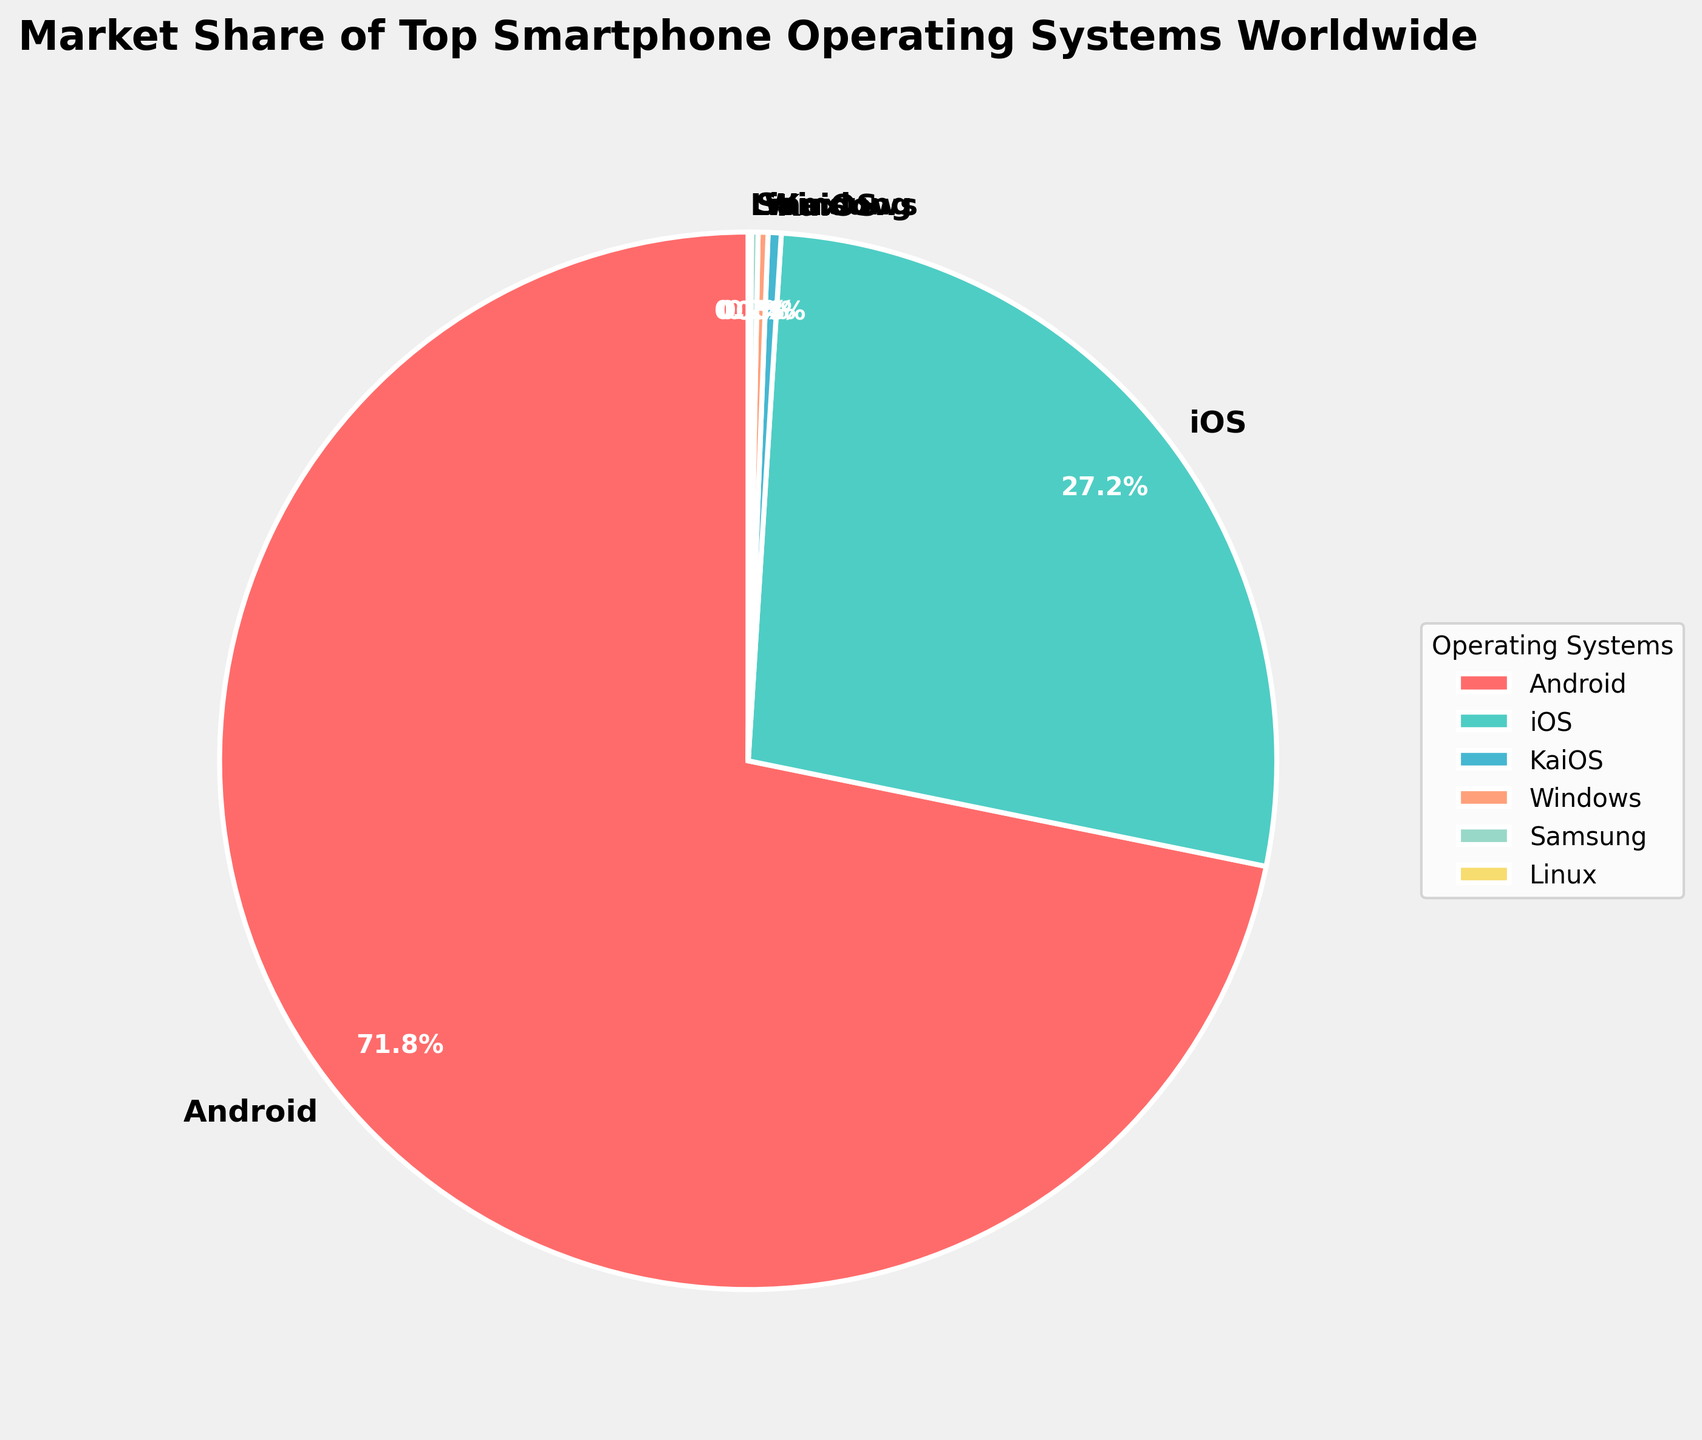What percentage of the market share is held by Android and iOS combined? Android holds 71.8% and iOS holds 27.2%. Adding these two percentages together gives 71.8 + 27.2 = 99.0%.
Answer: 99.0% Which operating system has a smaller market share, KaiOS or Windows? KaiOS holds 0.4% of the market share while Windows holds 0.3% of the market share. Comparatively, Windows has a smaller market share.
Answer: Windows What's the difference in market share between Android and iOS? Android's market share is 71.8% and iOS's market share is 27.2%. The difference between them is 71.8 - 27.2 = 44.6%.
Answer: 44.6% Which operating system has the least market share, and what is its percentage? The operating system with the least market share is Linux, with a market share of 0.1%.
Answer: Linux, 0.1% Is the combined market share of KaiOS, Windows, Samsung, and Linux greater than 1%? The market shares are 0.4% (KaiOS), 0.3% (Windows), 0.2% (Samsung), and 0.1% (Linux). Adding these together gives 0.4 + 0.3 + 0.2 + 0.1 = 1.0%. Therefore, their combined market share is exactly 1%.
Answer: No, it is exactly 1% How does the color of the slice representing Android compare to the color of the slice representing iOS? The slice representing Android is red, while the slice representing iOS is teal blue.
Answer: Android: red, iOS: teal blue By what percentage is Android's market share greater than Windows' market share? Android's market share is 71.8% and Windows' market share is 0.3%. The percentage difference can be calculated by (71.8 - 0.3) / 0.3 * 100 = 23800%.
Answer: 23800% Among the operating systems with a market share of less than 1%, which one has the largest share? The operating systems with market shares less than 1% are KaiOS (0.4%), Windows (0.3%), Samsung (0.2%), and Linux (0.1%). KaiOS has the largest share among them with 0.4%.
Answer: KaiOS What is the combined market share of all the operating systems except for Android and iOS? The other operating systems (KaiOS, Windows, Samsung, and Linux) have market shares of 0.4%, 0.3%, 0.2%, and 0.1% respectively. Summing these gives 0.4 + 0.3 + 0.2 + 0.1 = 1%.
Answer: 1% Are the labels of the slices and their respective percentages visually distinguishable? Yes, the labels are in bold font and the percentage labels are also bold, colored white, and placed within or near the slices, making them easily distinguishable.
Answer: Yes 